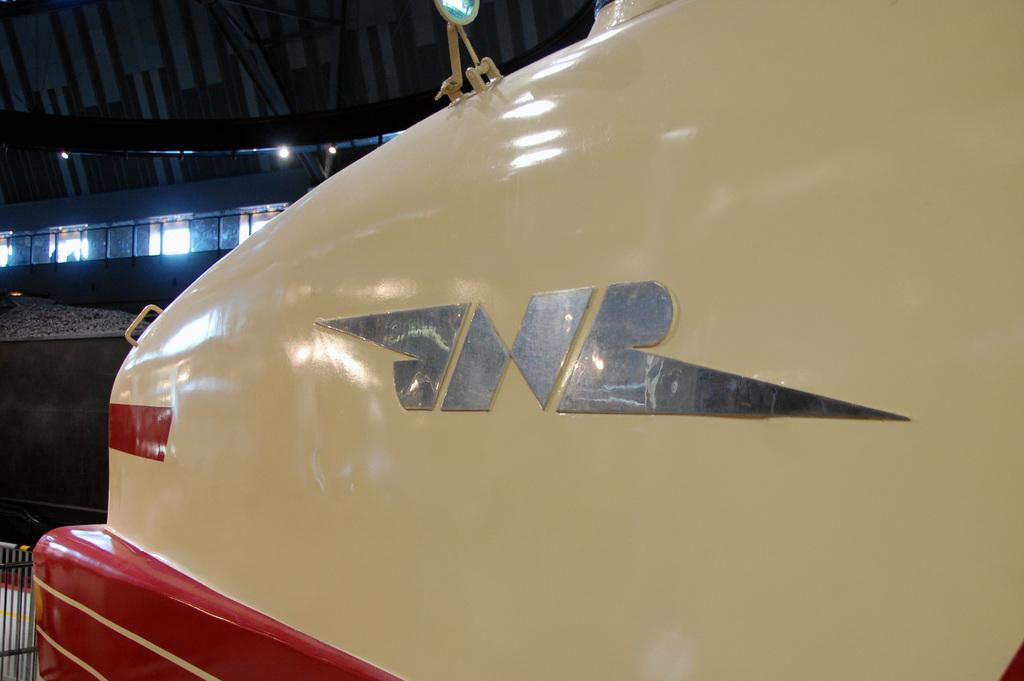What is the main subject of the image? There is a vehicle in the image. What type of net is being used to level the ground around the vehicle in the image? There is no net or leveling activity present in the image; it only features a vehicle. 